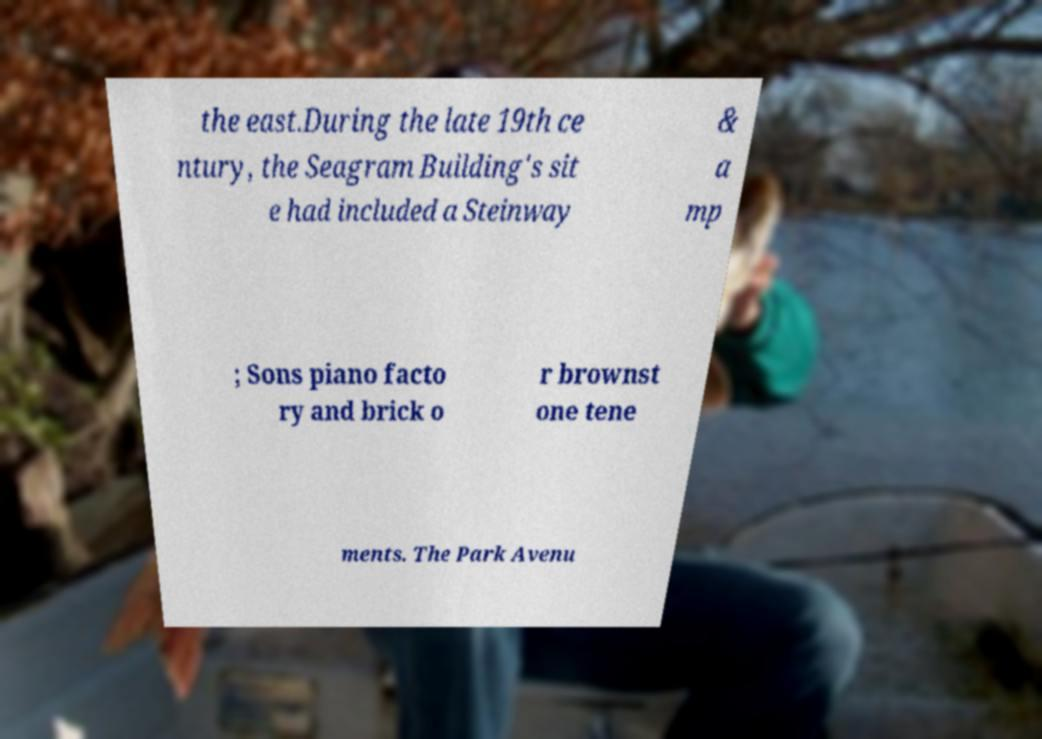Please identify and transcribe the text found in this image. the east.During the late 19th ce ntury, the Seagram Building's sit e had included a Steinway & a mp ; Sons piano facto ry and brick o r brownst one tene ments. The Park Avenu 